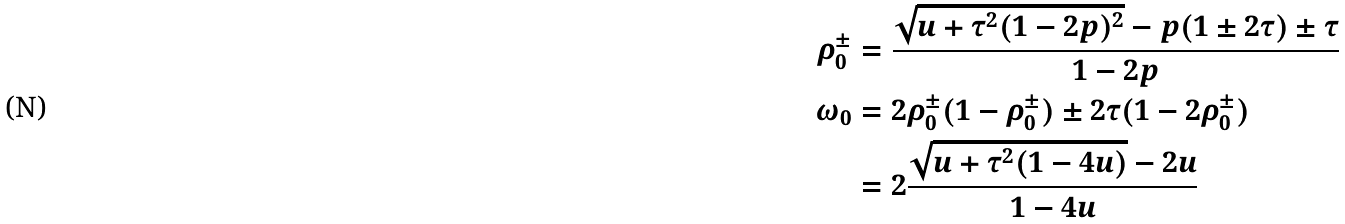<formula> <loc_0><loc_0><loc_500><loc_500>\rho _ { 0 } ^ { \pm } & = \frac { \sqrt { u + \tau ^ { 2 } ( 1 - 2 p ) ^ { 2 } } - p ( 1 \pm 2 \tau ) \pm \tau } { 1 - 2 p } \\ \omega _ { 0 } & = 2 \rho _ { 0 } ^ { \pm } ( 1 - \rho _ { 0 } ^ { \pm } ) \pm 2 \tau ( 1 - 2 \rho _ { 0 } ^ { \pm } ) \\ & = 2 \frac { \sqrt { u + \tau ^ { 2 } ( 1 - 4 u ) } - 2 u } { 1 - 4 u }</formula> 